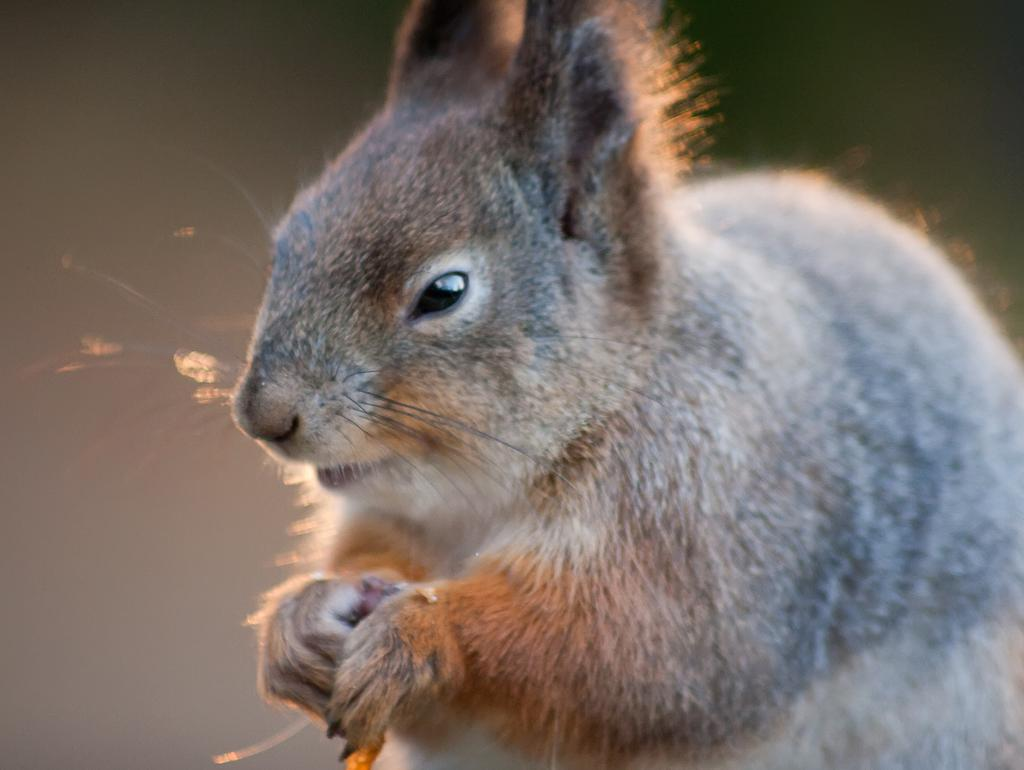What type of animal is featured in the image? The image contains a picture of a squirrel. What type of expansion is being performed on the kitten in the image? There is no kitten present in the image, and therefore no expansion is being performed. How many matches are visible in the image? There are no matches visible in the image. 